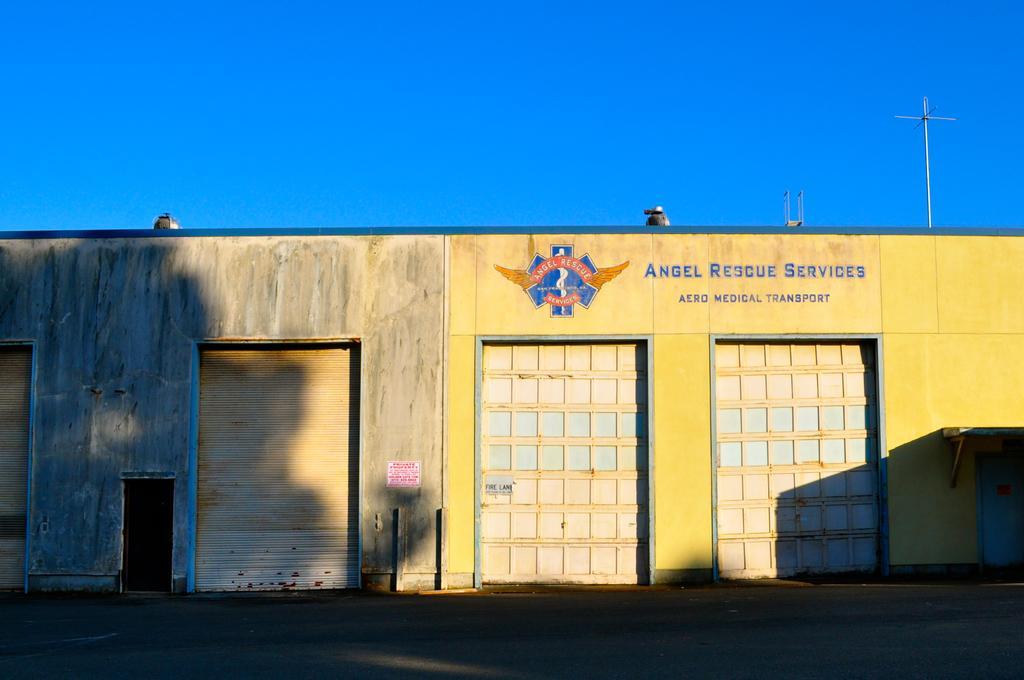Could you give a brief overview of what you see in this image? In this picture we can see text on the house, and we can see few shutters, in the background we can find few poles. 